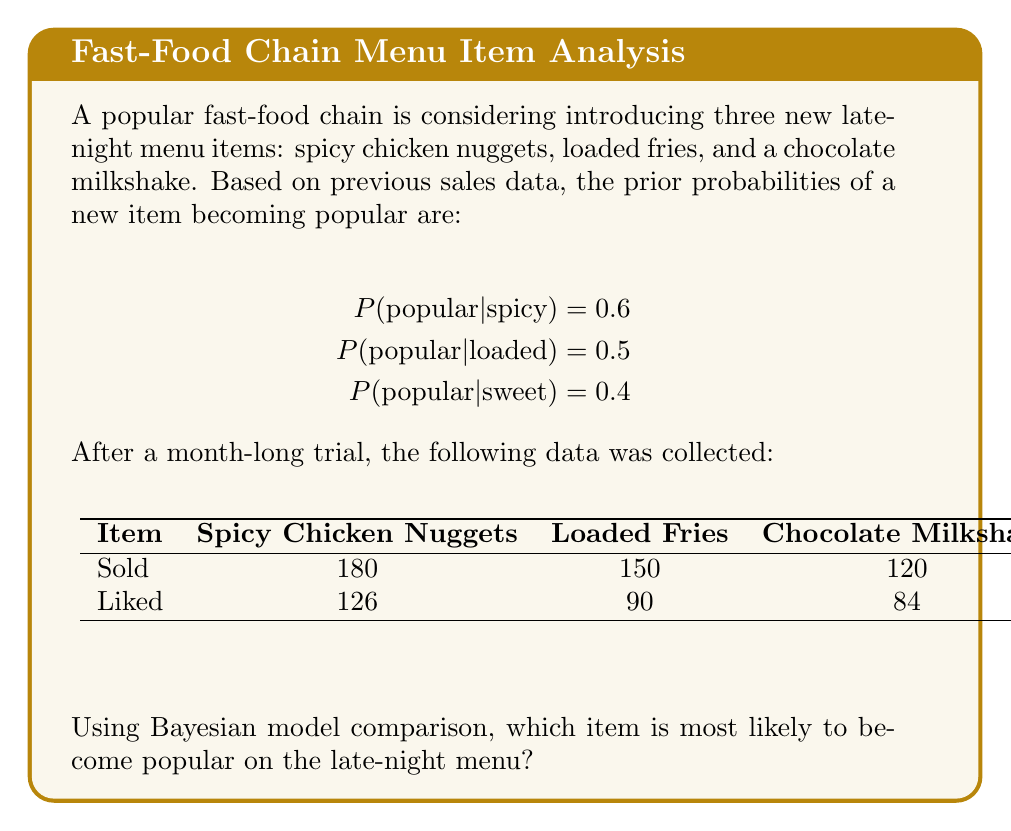Can you answer this question? To determine which item is most likely to become popular, we'll use Bayes' theorem to calculate the posterior probability for each item and compare them.

Bayes' theorem: $$P(A|B) = \frac{P(B|A) \cdot P(A)}{P(B)}$$

For each item, we'll calculate:
$$P(popular|data) = \frac{P(data|popular) \cdot P(popular)}{P(data)}$$

1. Spicy Chicken Nuggets:
   Prior: $P(popular) = 0.6$
   Likelihood: $P(data|popular) = \binom{180}{126} (0.7)^{126} (0.3)^{54}$
   (Assuming 70% of customers liking it indicates popularity)
   
   $$P(popular|data) = \frac{\binom{180}{126} (0.7)^{126} (0.3)^{54} \cdot 0.6}{\binom{180}{126} (0.7)^{126} (0.3)^{54} \cdot 0.6 + \binom{180}{126} (0.3)^{126} (0.7)^{54} \cdot 0.4}$$

2. Loaded Fries:
   Prior: $P(popular) = 0.5$
   Likelihood: $P(data|popular) = \binom{150}{90} (0.6)^{90} (0.4)^{60}$
   
   $$P(popular|data) = \frac{\binom{150}{90} (0.6)^{90} (0.4)^{60} \cdot 0.5}{\binom{150}{90} (0.6)^{90} (0.4)^{60} \cdot 0.5 + \binom{150}{90} (0.4)^{90} (0.6)^{60} \cdot 0.5}$$

3. Chocolate Milkshake:
   Prior: $P(popular) = 0.4$
   Likelihood: $P(data|popular) = \binom{120}{84} (0.7)^{84} (0.3)^{36}$
   
   $$P(popular|data) = \frac{\binom{120}{84} (0.7)^{84} (0.3)^{36} \cdot 0.4}{\binom{120}{84} (0.7)^{84} (0.3)^{36} \cdot 0.4 + \binom{120}{84} (0.3)^{84} (0.7)^{36} \cdot 0.6}$$

Calculating these probabilities (which can be done using a calculator or computer), we get:

1. Spicy Chicken Nuggets: $P(popular|data) \approx 0.9999$
2. Loaded Fries: $P(popular|data) \approx 0.9728$
3. Chocolate Milkshake: $P(popular|data) \approx 0.9997$

The item with the highest posterior probability is most likely to become popular.
Answer: Spicy Chicken Nuggets 